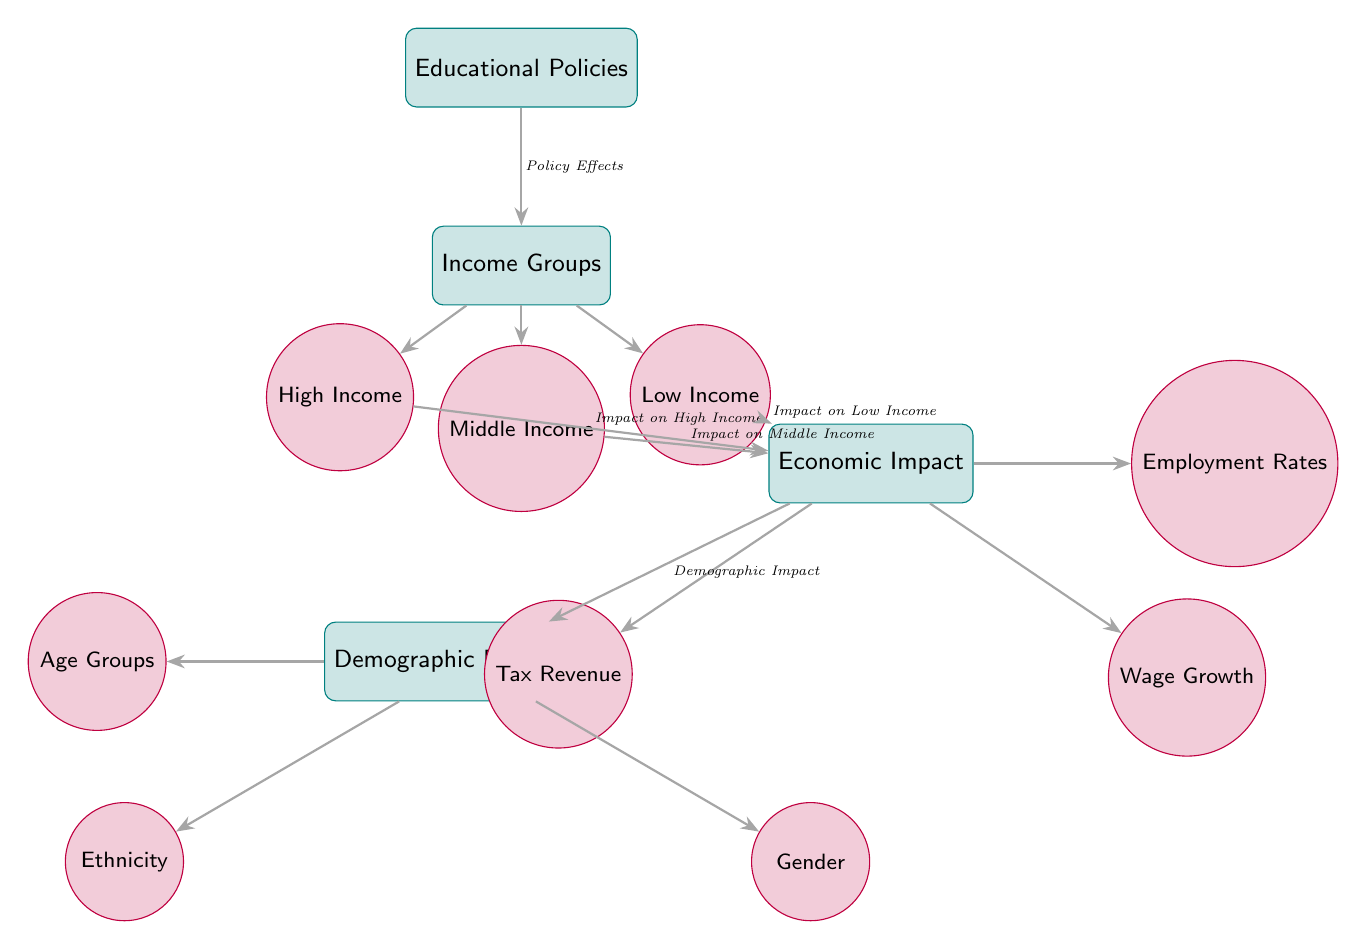What are the three income groups represented in the diagram? The diagram explicitly identifies three income groups: High Income, Middle Income, and Low Income, depicted as separate nodes below the "Income Groups" node.
Answer: High Income, Middle Income, Low Income What is the relationship depicted between "Educational Policies" and "Income Groups"? The diagram shows an arrow from "Educational Policies" to "Income Groups," labeled "Policy Effects." This indicates that the effects of educational policies directly influence the different income groups.
Answer: Policy Effects How many types of economic impacts are shown in the diagram? The diagram indicates three types of economic impacts stemming from the "Economic Impact" node: Employment Rates, Wage Growth, and Tax Revenue, each represented by a separate node.
Answer: Three Which income group impacts wage growth? Each income group (High Income, Middle Income, Low Income) influences wage growth according to the arrows leading toward the "Economic Impact" node. Thus, the impacts of educational policies on wage growth are associated with all three income groups.
Answer: High Income, Middle Income, Low Income What demographic categories are influenced by the economic impact? Under the "Demographic Breakdown" node, the diagram includes three demographic categories that are affected by economic impacts: Age Groups, Ethnicity, and Gender. Hence, all these demographic factors play a role in understanding the impact of education policies.
Answer: Age Groups, Ethnicity, Gender How does the "Demographic Breakdown" relate to economic impact? The diagram illustrates an arrow labeled "Demographic Impact" from the "Economic Impact" node to the "Demographic Breakdown" node, indicating that the outcomes of economic impacts influence various demographic characteristics.
Answer: Demographic Impact Which economic impact is directly linked to tax revenue? The diagram indicates that "Tax Revenue" is one of the economic impacts stemming from the "Economic Impact" node, thus showing a direct link to tax-related outcomes influenced by educational policies.
Answer: Tax Revenue How many edges are there between income groups and economic impacts? Each income group connects separately to the "Economic Impact" node; thus, there are three edges from income groups leading to one economic impact node. Therefore, the total number of edges is three.
Answer: Three 